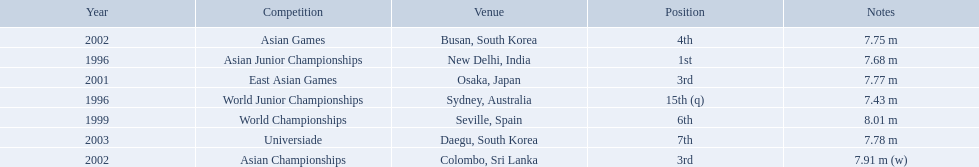What jumps did huang le make in 2002? 7.91 m (w), 7.75 m. Which jump was the longest? 7.91 m (w). 